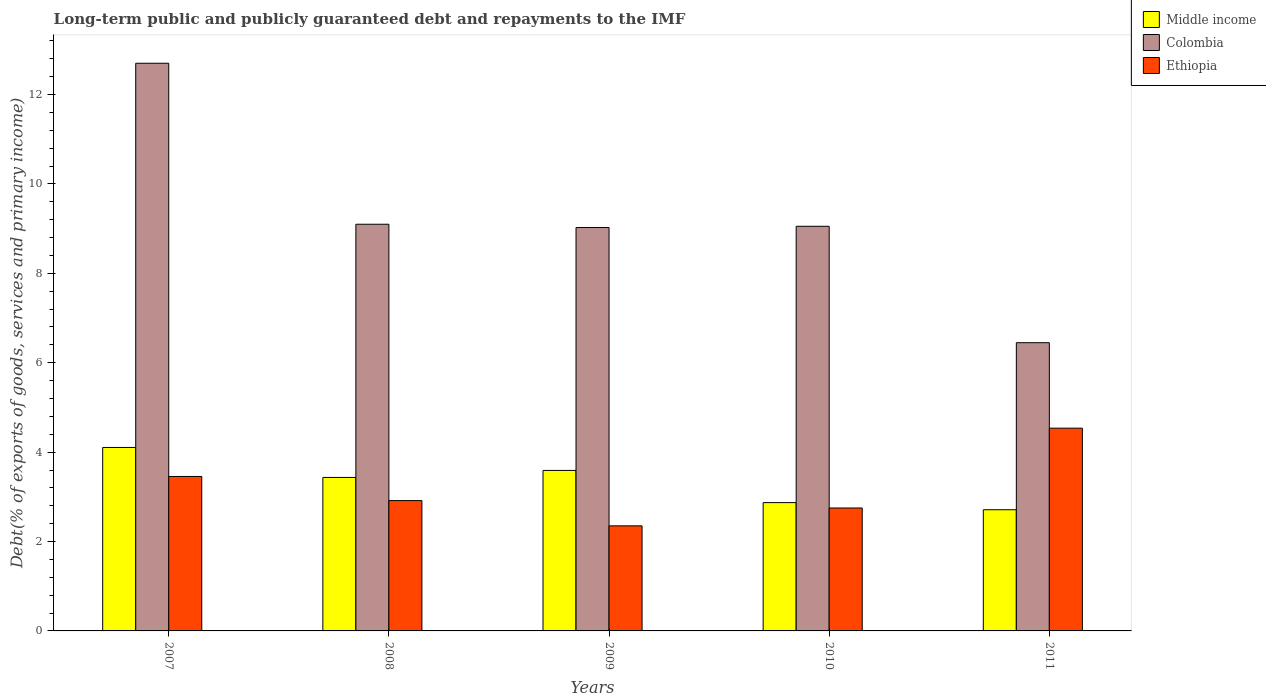How many different coloured bars are there?
Provide a short and direct response. 3. How many groups of bars are there?
Offer a very short reply. 5. Are the number of bars per tick equal to the number of legend labels?
Make the answer very short. Yes. What is the label of the 4th group of bars from the left?
Give a very brief answer. 2010. What is the debt and repayments in Middle income in 2010?
Your response must be concise. 2.87. Across all years, what is the maximum debt and repayments in Middle income?
Keep it short and to the point. 4.1. Across all years, what is the minimum debt and repayments in Colombia?
Your response must be concise. 6.45. In which year was the debt and repayments in Ethiopia minimum?
Keep it short and to the point. 2009. What is the total debt and repayments in Colombia in the graph?
Offer a very short reply. 46.32. What is the difference between the debt and repayments in Middle income in 2007 and that in 2011?
Offer a very short reply. 1.39. What is the difference between the debt and repayments in Colombia in 2010 and the debt and repayments in Ethiopia in 2009?
Offer a terse response. 6.7. What is the average debt and repayments in Middle income per year?
Your answer should be very brief. 3.34. In the year 2008, what is the difference between the debt and repayments in Ethiopia and debt and repayments in Middle income?
Your response must be concise. -0.52. In how many years, is the debt and repayments in Middle income greater than 2.4 %?
Provide a short and direct response. 5. What is the ratio of the debt and repayments in Ethiopia in 2007 to that in 2009?
Your answer should be very brief. 1.47. Is the debt and repayments in Ethiopia in 2008 less than that in 2009?
Your answer should be compact. No. Is the difference between the debt and repayments in Ethiopia in 2008 and 2010 greater than the difference between the debt and repayments in Middle income in 2008 and 2010?
Offer a terse response. No. What is the difference between the highest and the second highest debt and repayments in Ethiopia?
Provide a short and direct response. 1.08. What is the difference between the highest and the lowest debt and repayments in Ethiopia?
Ensure brevity in your answer.  2.19. In how many years, is the debt and repayments in Ethiopia greater than the average debt and repayments in Ethiopia taken over all years?
Your answer should be compact. 2. Is the sum of the debt and repayments in Ethiopia in 2009 and 2010 greater than the maximum debt and repayments in Colombia across all years?
Make the answer very short. No. What does the 1st bar from the right in 2007 represents?
Keep it short and to the point. Ethiopia. How many bars are there?
Make the answer very short. 15. Are all the bars in the graph horizontal?
Provide a succinct answer. No. How many years are there in the graph?
Ensure brevity in your answer.  5. What is the difference between two consecutive major ticks on the Y-axis?
Give a very brief answer. 2. Does the graph contain any zero values?
Make the answer very short. No. Where does the legend appear in the graph?
Your answer should be compact. Top right. How many legend labels are there?
Ensure brevity in your answer.  3. How are the legend labels stacked?
Keep it short and to the point. Vertical. What is the title of the graph?
Your answer should be very brief. Long-term public and publicly guaranteed debt and repayments to the IMF. What is the label or title of the X-axis?
Give a very brief answer. Years. What is the label or title of the Y-axis?
Your response must be concise. Debt(% of exports of goods, services and primary income). What is the Debt(% of exports of goods, services and primary income) in Middle income in 2007?
Provide a succinct answer. 4.1. What is the Debt(% of exports of goods, services and primary income) in Colombia in 2007?
Provide a short and direct response. 12.7. What is the Debt(% of exports of goods, services and primary income) in Ethiopia in 2007?
Your response must be concise. 3.46. What is the Debt(% of exports of goods, services and primary income) in Middle income in 2008?
Your answer should be compact. 3.43. What is the Debt(% of exports of goods, services and primary income) in Colombia in 2008?
Offer a very short reply. 9.1. What is the Debt(% of exports of goods, services and primary income) of Ethiopia in 2008?
Your answer should be compact. 2.92. What is the Debt(% of exports of goods, services and primary income) of Middle income in 2009?
Keep it short and to the point. 3.59. What is the Debt(% of exports of goods, services and primary income) in Colombia in 2009?
Your answer should be compact. 9.02. What is the Debt(% of exports of goods, services and primary income) of Ethiopia in 2009?
Offer a terse response. 2.35. What is the Debt(% of exports of goods, services and primary income) in Middle income in 2010?
Your answer should be compact. 2.87. What is the Debt(% of exports of goods, services and primary income) of Colombia in 2010?
Your response must be concise. 9.05. What is the Debt(% of exports of goods, services and primary income) of Ethiopia in 2010?
Your answer should be very brief. 2.75. What is the Debt(% of exports of goods, services and primary income) of Middle income in 2011?
Provide a short and direct response. 2.71. What is the Debt(% of exports of goods, services and primary income) of Colombia in 2011?
Your answer should be compact. 6.45. What is the Debt(% of exports of goods, services and primary income) in Ethiopia in 2011?
Offer a terse response. 4.54. Across all years, what is the maximum Debt(% of exports of goods, services and primary income) of Middle income?
Ensure brevity in your answer.  4.1. Across all years, what is the maximum Debt(% of exports of goods, services and primary income) of Colombia?
Your answer should be compact. 12.7. Across all years, what is the maximum Debt(% of exports of goods, services and primary income) in Ethiopia?
Provide a short and direct response. 4.54. Across all years, what is the minimum Debt(% of exports of goods, services and primary income) of Middle income?
Keep it short and to the point. 2.71. Across all years, what is the minimum Debt(% of exports of goods, services and primary income) of Colombia?
Your answer should be very brief. 6.45. Across all years, what is the minimum Debt(% of exports of goods, services and primary income) of Ethiopia?
Your answer should be compact. 2.35. What is the total Debt(% of exports of goods, services and primary income) in Middle income in the graph?
Provide a short and direct response. 16.71. What is the total Debt(% of exports of goods, services and primary income) of Colombia in the graph?
Make the answer very short. 46.32. What is the total Debt(% of exports of goods, services and primary income) of Ethiopia in the graph?
Give a very brief answer. 16.01. What is the difference between the Debt(% of exports of goods, services and primary income) of Middle income in 2007 and that in 2008?
Ensure brevity in your answer.  0.67. What is the difference between the Debt(% of exports of goods, services and primary income) of Colombia in 2007 and that in 2008?
Ensure brevity in your answer.  3.6. What is the difference between the Debt(% of exports of goods, services and primary income) of Ethiopia in 2007 and that in 2008?
Make the answer very short. 0.54. What is the difference between the Debt(% of exports of goods, services and primary income) of Middle income in 2007 and that in 2009?
Your answer should be compact. 0.51. What is the difference between the Debt(% of exports of goods, services and primary income) of Colombia in 2007 and that in 2009?
Offer a very short reply. 3.68. What is the difference between the Debt(% of exports of goods, services and primary income) in Ethiopia in 2007 and that in 2009?
Ensure brevity in your answer.  1.1. What is the difference between the Debt(% of exports of goods, services and primary income) of Middle income in 2007 and that in 2010?
Provide a succinct answer. 1.23. What is the difference between the Debt(% of exports of goods, services and primary income) in Colombia in 2007 and that in 2010?
Ensure brevity in your answer.  3.65. What is the difference between the Debt(% of exports of goods, services and primary income) in Ethiopia in 2007 and that in 2010?
Offer a terse response. 0.71. What is the difference between the Debt(% of exports of goods, services and primary income) in Middle income in 2007 and that in 2011?
Ensure brevity in your answer.  1.39. What is the difference between the Debt(% of exports of goods, services and primary income) in Colombia in 2007 and that in 2011?
Provide a succinct answer. 6.25. What is the difference between the Debt(% of exports of goods, services and primary income) in Ethiopia in 2007 and that in 2011?
Offer a terse response. -1.08. What is the difference between the Debt(% of exports of goods, services and primary income) in Middle income in 2008 and that in 2009?
Keep it short and to the point. -0.16. What is the difference between the Debt(% of exports of goods, services and primary income) in Colombia in 2008 and that in 2009?
Provide a short and direct response. 0.07. What is the difference between the Debt(% of exports of goods, services and primary income) in Ethiopia in 2008 and that in 2009?
Give a very brief answer. 0.56. What is the difference between the Debt(% of exports of goods, services and primary income) in Middle income in 2008 and that in 2010?
Ensure brevity in your answer.  0.56. What is the difference between the Debt(% of exports of goods, services and primary income) in Colombia in 2008 and that in 2010?
Give a very brief answer. 0.05. What is the difference between the Debt(% of exports of goods, services and primary income) in Ethiopia in 2008 and that in 2010?
Give a very brief answer. 0.17. What is the difference between the Debt(% of exports of goods, services and primary income) in Middle income in 2008 and that in 2011?
Give a very brief answer. 0.72. What is the difference between the Debt(% of exports of goods, services and primary income) in Colombia in 2008 and that in 2011?
Ensure brevity in your answer.  2.65. What is the difference between the Debt(% of exports of goods, services and primary income) of Ethiopia in 2008 and that in 2011?
Your answer should be very brief. -1.62. What is the difference between the Debt(% of exports of goods, services and primary income) of Middle income in 2009 and that in 2010?
Offer a terse response. 0.72. What is the difference between the Debt(% of exports of goods, services and primary income) of Colombia in 2009 and that in 2010?
Your answer should be very brief. -0.03. What is the difference between the Debt(% of exports of goods, services and primary income) in Ethiopia in 2009 and that in 2010?
Your answer should be very brief. -0.4. What is the difference between the Debt(% of exports of goods, services and primary income) in Middle income in 2009 and that in 2011?
Your answer should be very brief. 0.88. What is the difference between the Debt(% of exports of goods, services and primary income) in Colombia in 2009 and that in 2011?
Your answer should be compact. 2.58. What is the difference between the Debt(% of exports of goods, services and primary income) of Ethiopia in 2009 and that in 2011?
Keep it short and to the point. -2.19. What is the difference between the Debt(% of exports of goods, services and primary income) of Middle income in 2010 and that in 2011?
Ensure brevity in your answer.  0.16. What is the difference between the Debt(% of exports of goods, services and primary income) of Colombia in 2010 and that in 2011?
Provide a short and direct response. 2.6. What is the difference between the Debt(% of exports of goods, services and primary income) in Ethiopia in 2010 and that in 2011?
Your answer should be compact. -1.79. What is the difference between the Debt(% of exports of goods, services and primary income) in Middle income in 2007 and the Debt(% of exports of goods, services and primary income) in Colombia in 2008?
Ensure brevity in your answer.  -4.99. What is the difference between the Debt(% of exports of goods, services and primary income) in Middle income in 2007 and the Debt(% of exports of goods, services and primary income) in Ethiopia in 2008?
Your answer should be compact. 1.19. What is the difference between the Debt(% of exports of goods, services and primary income) of Colombia in 2007 and the Debt(% of exports of goods, services and primary income) of Ethiopia in 2008?
Provide a succinct answer. 9.78. What is the difference between the Debt(% of exports of goods, services and primary income) of Middle income in 2007 and the Debt(% of exports of goods, services and primary income) of Colombia in 2009?
Offer a terse response. -4.92. What is the difference between the Debt(% of exports of goods, services and primary income) of Middle income in 2007 and the Debt(% of exports of goods, services and primary income) of Ethiopia in 2009?
Provide a short and direct response. 1.75. What is the difference between the Debt(% of exports of goods, services and primary income) of Colombia in 2007 and the Debt(% of exports of goods, services and primary income) of Ethiopia in 2009?
Ensure brevity in your answer.  10.35. What is the difference between the Debt(% of exports of goods, services and primary income) in Middle income in 2007 and the Debt(% of exports of goods, services and primary income) in Colombia in 2010?
Your answer should be compact. -4.95. What is the difference between the Debt(% of exports of goods, services and primary income) in Middle income in 2007 and the Debt(% of exports of goods, services and primary income) in Ethiopia in 2010?
Your answer should be very brief. 1.35. What is the difference between the Debt(% of exports of goods, services and primary income) of Colombia in 2007 and the Debt(% of exports of goods, services and primary income) of Ethiopia in 2010?
Keep it short and to the point. 9.95. What is the difference between the Debt(% of exports of goods, services and primary income) in Middle income in 2007 and the Debt(% of exports of goods, services and primary income) in Colombia in 2011?
Your answer should be compact. -2.34. What is the difference between the Debt(% of exports of goods, services and primary income) of Middle income in 2007 and the Debt(% of exports of goods, services and primary income) of Ethiopia in 2011?
Your answer should be compact. -0.43. What is the difference between the Debt(% of exports of goods, services and primary income) in Colombia in 2007 and the Debt(% of exports of goods, services and primary income) in Ethiopia in 2011?
Your answer should be very brief. 8.16. What is the difference between the Debt(% of exports of goods, services and primary income) in Middle income in 2008 and the Debt(% of exports of goods, services and primary income) in Colombia in 2009?
Make the answer very short. -5.59. What is the difference between the Debt(% of exports of goods, services and primary income) of Middle income in 2008 and the Debt(% of exports of goods, services and primary income) of Ethiopia in 2009?
Make the answer very short. 1.08. What is the difference between the Debt(% of exports of goods, services and primary income) of Colombia in 2008 and the Debt(% of exports of goods, services and primary income) of Ethiopia in 2009?
Make the answer very short. 6.75. What is the difference between the Debt(% of exports of goods, services and primary income) of Middle income in 2008 and the Debt(% of exports of goods, services and primary income) of Colombia in 2010?
Offer a terse response. -5.62. What is the difference between the Debt(% of exports of goods, services and primary income) in Middle income in 2008 and the Debt(% of exports of goods, services and primary income) in Ethiopia in 2010?
Provide a short and direct response. 0.68. What is the difference between the Debt(% of exports of goods, services and primary income) in Colombia in 2008 and the Debt(% of exports of goods, services and primary income) in Ethiopia in 2010?
Offer a terse response. 6.35. What is the difference between the Debt(% of exports of goods, services and primary income) of Middle income in 2008 and the Debt(% of exports of goods, services and primary income) of Colombia in 2011?
Offer a very short reply. -3.01. What is the difference between the Debt(% of exports of goods, services and primary income) in Middle income in 2008 and the Debt(% of exports of goods, services and primary income) in Ethiopia in 2011?
Your answer should be compact. -1.1. What is the difference between the Debt(% of exports of goods, services and primary income) of Colombia in 2008 and the Debt(% of exports of goods, services and primary income) of Ethiopia in 2011?
Give a very brief answer. 4.56. What is the difference between the Debt(% of exports of goods, services and primary income) in Middle income in 2009 and the Debt(% of exports of goods, services and primary income) in Colombia in 2010?
Provide a succinct answer. -5.46. What is the difference between the Debt(% of exports of goods, services and primary income) in Middle income in 2009 and the Debt(% of exports of goods, services and primary income) in Ethiopia in 2010?
Your answer should be very brief. 0.84. What is the difference between the Debt(% of exports of goods, services and primary income) in Colombia in 2009 and the Debt(% of exports of goods, services and primary income) in Ethiopia in 2010?
Your answer should be very brief. 6.27. What is the difference between the Debt(% of exports of goods, services and primary income) of Middle income in 2009 and the Debt(% of exports of goods, services and primary income) of Colombia in 2011?
Provide a succinct answer. -2.86. What is the difference between the Debt(% of exports of goods, services and primary income) in Middle income in 2009 and the Debt(% of exports of goods, services and primary income) in Ethiopia in 2011?
Provide a short and direct response. -0.95. What is the difference between the Debt(% of exports of goods, services and primary income) of Colombia in 2009 and the Debt(% of exports of goods, services and primary income) of Ethiopia in 2011?
Provide a succinct answer. 4.49. What is the difference between the Debt(% of exports of goods, services and primary income) of Middle income in 2010 and the Debt(% of exports of goods, services and primary income) of Colombia in 2011?
Make the answer very short. -3.58. What is the difference between the Debt(% of exports of goods, services and primary income) of Middle income in 2010 and the Debt(% of exports of goods, services and primary income) of Ethiopia in 2011?
Provide a short and direct response. -1.67. What is the difference between the Debt(% of exports of goods, services and primary income) of Colombia in 2010 and the Debt(% of exports of goods, services and primary income) of Ethiopia in 2011?
Provide a succinct answer. 4.52. What is the average Debt(% of exports of goods, services and primary income) in Middle income per year?
Your answer should be very brief. 3.34. What is the average Debt(% of exports of goods, services and primary income) in Colombia per year?
Your response must be concise. 9.26. What is the average Debt(% of exports of goods, services and primary income) in Ethiopia per year?
Make the answer very short. 3.2. In the year 2007, what is the difference between the Debt(% of exports of goods, services and primary income) in Middle income and Debt(% of exports of goods, services and primary income) in Colombia?
Ensure brevity in your answer.  -8.6. In the year 2007, what is the difference between the Debt(% of exports of goods, services and primary income) of Middle income and Debt(% of exports of goods, services and primary income) of Ethiopia?
Provide a succinct answer. 0.65. In the year 2007, what is the difference between the Debt(% of exports of goods, services and primary income) in Colombia and Debt(% of exports of goods, services and primary income) in Ethiopia?
Keep it short and to the point. 9.24. In the year 2008, what is the difference between the Debt(% of exports of goods, services and primary income) in Middle income and Debt(% of exports of goods, services and primary income) in Colombia?
Make the answer very short. -5.66. In the year 2008, what is the difference between the Debt(% of exports of goods, services and primary income) in Middle income and Debt(% of exports of goods, services and primary income) in Ethiopia?
Give a very brief answer. 0.52. In the year 2008, what is the difference between the Debt(% of exports of goods, services and primary income) of Colombia and Debt(% of exports of goods, services and primary income) of Ethiopia?
Provide a succinct answer. 6.18. In the year 2009, what is the difference between the Debt(% of exports of goods, services and primary income) of Middle income and Debt(% of exports of goods, services and primary income) of Colombia?
Make the answer very short. -5.43. In the year 2009, what is the difference between the Debt(% of exports of goods, services and primary income) in Middle income and Debt(% of exports of goods, services and primary income) in Ethiopia?
Your answer should be compact. 1.24. In the year 2009, what is the difference between the Debt(% of exports of goods, services and primary income) of Colombia and Debt(% of exports of goods, services and primary income) of Ethiopia?
Your response must be concise. 6.67. In the year 2010, what is the difference between the Debt(% of exports of goods, services and primary income) of Middle income and Debt(% of exports of goods, services and primary income) of Colombia?
Your answer should be very brief. -6.18. In the year 2010, what is the difference between the Debt(% of exports of goods, services and primary income) in Middle income and Debt(% of exports of goods, services and primary income) in Ethiopia?
Provide a succinct answer. 0.12. In the year 2010, what is the difference between the Debt(% of exports of goods, services and primary income) of Colombia and Debt(% of exports of goods, services and primary income) of Ethiopia?
Your answer should be very brief. 6.3. In the year 2011, what is the difference between the Debt(% of exports of goods, services and primary income) in Middle income and Debt(% of exports of goods, services and primary income) in Colombia?
Offer a very short reply. -3.74. In the year 2011, what is the difference between the Debt(% of exports of goods, services and primary income) of Middle income and Debt(% of exports of goods, services and primary income) of Ethiopia?
Your answer should be very brief. -1.82. In the year 2011, what is the difference between the Debt(% of exports of goods, services and primary income) in Colombia and Debt(% of exports of goods, services and primary income) in Ethiopia?
Ensure brevity in your answer.  1.91. What is the ratio of the Debt(% of exports of goods, services and primary income) of Middle income in 2007 to that in 2008?
Make the answer very short. 1.2. What is the ratio of the Debt(% of exports of goods, services and primary income) in Colombia in 2007 to that in 2008?
Provide a succinct answer. 1.4. What is the ratio of the Debt(% of exports of goods, services and primary income) of Ethiopia in 2007 to that in 2008?
Your response must be concise. 1.19. What is the ratio of the Debt(% of exports of goods, services and primary income) in Middle income in 2007 to that in 2009?
Provide a succinct answer. 1.14. What is the ratio of the Debt(% of exports of goods, services and primary income) of Colombia in 2007 to that in 2009?
Your answer should be compact. 1.41. What is the ratio of the Debt(% of exports of goods, services and primary income) in Ethiopia in 2007 to that in 2009?
Ensure brevity in your answer.  1.47. What is the ratio of the Debt(% of exports of goods, services and primary income) of Middle income in 2007 to that in 2010?
Provide a succinct answer. 1.43. What is the ratio of the Debt(% of exports of goods, services and primary income) in Colombia in 2007 to that in 2010?
Your response must be concise. 1.4. What is the ratio of the Debt(% of exports of goods, services and primary income) in Ethiopia in 2007 to that in 2010?
Make the answer very short. 1.26. What is the ratio of the Debt(% of exports of goods, services and primary income) in Middle income in 2007 to that in 2011?
Keep it short and to the point. 1.51. What is the ratio of the Debt(% of exports of goods, services and primary income) in Colombia in 2007 to that in 2011?
Provide a short and direct response. 1.97. What is the ratio of the Debt(% of exports of goods, services and primary income) in Ethiopia in 2007 to that in 2011?
Make the answer very short. 0.76. What is the ratio of the Debt(% of exports of goods, services and primary income) in Middle income in 2008 to that in 2009?
Keep it short and to the point. 0.96. What is the ratio of the Debt(% of exports of goods, services and primary income) of Ethiopia in 2008 to that in 2009?
Your answer should be very brief. 1.24. What is the ratio of the Debt(% of exports of goods, services and primary income) of Middle income in 2008 to that in 2010?
Your answer should be very brief. 1.2. What is the ratio of the Debt(% of exports of goods, services and primary income) in Colombia in 2008 to that in 2010?
Your answer should be compact. 1.01. What is the ratio of the Debt(% of exports of goods, services and primary income) in Ethiopia in 2008 to that in 2010?
Your answer should be very brief. 1.06. What is the ratio of the Debt(% of exports of goods, services and primary income) of Middle income in 2008 to that in 2011?
Make the answer very short. 1.27. What is the ratio of the Debt(% of exports of goods, services and primary income) in Colombia in 2008 to that in 2011?
Your answer should be compact. 1.41. What is the ratio of the Debt(% of exports of goods, services and primary income) of Ethiopia in 2008 to that in 2011?
Offer a very short reply. 0.64. What is the ratio of the Debt(% of exports of goods, services and primary income) of Middle income in 2009 to that in 2010?
Your answer should be very brief. 1.25. What is the ratio of the Debt(% of exports of goods, services and primary income) of Ethiopia in 2009 to that in 2010?
Your response must be concise. 0.85. What is the ratio of the Debt(% of exports of goods, services and primary income) in Middle income in 2009 to that in 2011?
Provide a short and direct response. 1.32. What is the ratio of the Debt(% of exports of goods, services and primary income) of Colombia in 2009 to that in 2011?
Give a very brief answer. 1.4. What is the ratio of the Debt(% of exports of goods, services and primary income) in Ethiopia in 2009 to that in 2011?
Offer a terse response. 0.52. What is the ratio of the Debt(% of exports of goods, services and primary income) in Middle income in 2010 to that in 2011?
Make the answer very short. 1.06. What is the ratio of the Debt(% of exports of goods, services and primary income) in Colombia in 2010 to that in 2011?
Provide a succinct answer. 1.4. What is the ratio of the Debt(% of exports of goods, services and primary income) of Ethiopia in 2010 to that in 2011?
Provide a short and direct response. 0.61. What is the difference between the highest and the second highest Debt(% of exports of goods, services and primary income) of Middle income?
Ensure brevity in your answer.  0.51. What is the difference between the highest and the second highest Debt(% of exports of goods, services and primary income) in Colombia?
Provide a succinct answer. 3.6. What is the difference between the highest and the second highest Debt(% of exports of goods, services and primary income) of Ethiopia?
Offer a very short reply. 1.08. What is the difference between the highest and the lowest Debt(% of exports of goods, services and primary income) of Middle income?
Provide a succinct answer. 1.39. What is the difference between the highest and the lowest Debt(% of exports of goods, services and primary income) of Colombia?
Give a very brief answer. 6.25. What is the difference between the highest and the lowest Debt(% of exports of goods, services and primary income) of Ethiopia?
Give a very brief answer. 2.19. 